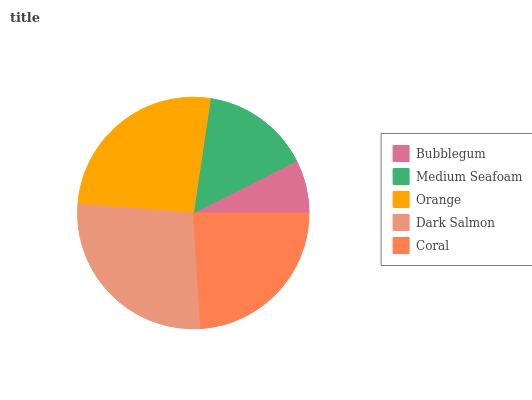Is Bubblegum the minimum?
Answer yes or no. Yes. Is Dark Salmon the maximum?
Answer yes or no. Yes. Is Medium Seafoam the minimum?
Answer yes or no. No. Is Medium Seafoam the maximum?
Answer yes or no. No. Is Medium Seafoam greater than Bubblegum?
Answer yes or no. Yes. Is Bubblegum less than Medium Seafoam?
Answer yes or no. Yes. Is Bubblegum greater than Medium Seafoam?
Answer yes or no. No. Is Medium Seafoam less than Bubblegum?
Answer yes or no. No. Is Coral the high median?
Answer yes or no. Yes. Is Coral the low median?
Answer yes or no. Yes. Is Orange the high median?
Answer yes or no. No. Is Medium Seafoam the low median?
Answer yes or no. No. 